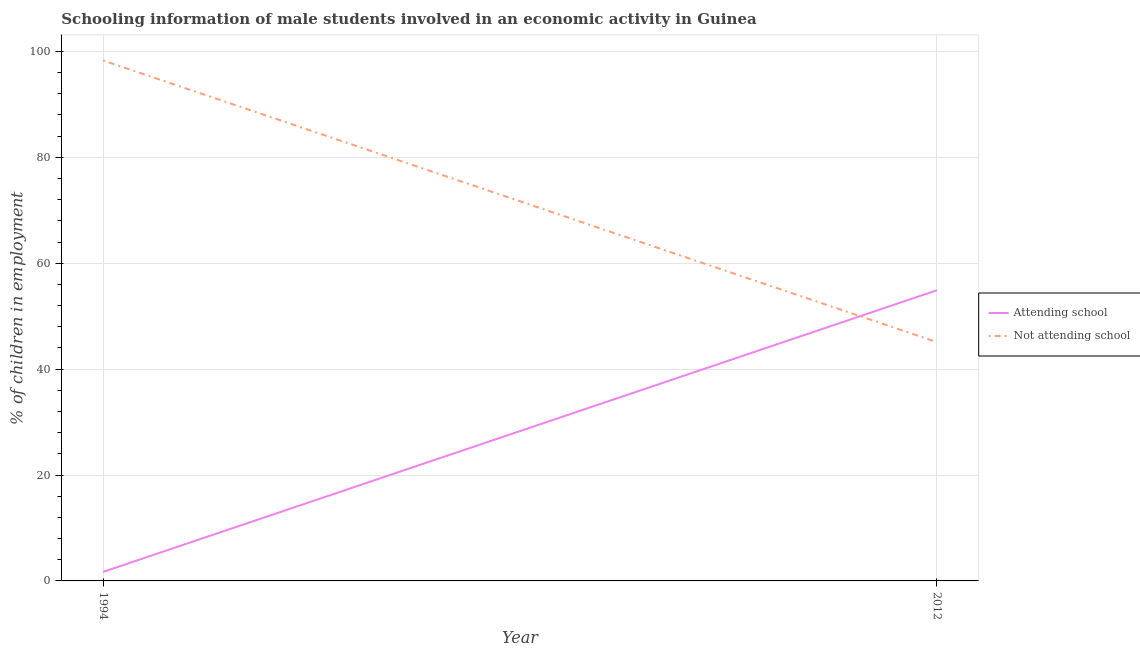Is the number of lines equal to the number of legend labels?
Your response must be concise. Yes. What is the percentage of employed males who are attending school in 2012?
Keep it short and to the point. 54.9. Across all years, what is the maximum percentage of employed males who are not attending school?
Make the answer very short. 98.3. Across all years, what is the minimum percentage of employed males who are attending school?
Keep it short and to the point. 1.7. In which year was the percentage of employed males who are attending school maximum?
Offer a terse response. 2012. In which year was the percentage of employed males who are not attending school minimum?
Ensure brevity in your answer.  2012. What is the total percentage of employed males who are attending school in the graph?
Ensure brevity in your answer.  56.6. What is the difference between the percentage of employed males who are not attending school in 1994 and that in 2012?
Provide a succinct answer. 53.2. What is the difference between the percentage of employed males who are attending school in 1994 and the percentage of employed males who are not attending school in 2012?
Offer a terse response. -43.4. What is the average percentage of employed males who are attending school per year?
Offer a terse response. 28.3. In the year 1994, what is the difference between the percentage of employed males who are not attending school and percentage of employed males who are attending school?
Your answer should be compact. 96.6. In how many years, is the percentage of employed males who are attending school greater than 16 %?
Your answer should be very brief. 1. What is the ratio of the percentage of employed males who are not attending school in 1994 to that in 2012?
Provide a succinct answer. 2.18. Is the percentage of employed males who are not attending school in 1994 less than that in 2012?
Offer a very short reply. No. Is the percentage of employed males who are not attending school strictly greater than the percentage of employed males who are attending school over the years?
Provide a short and direct response. No. What is the difference between two consecutive major ticks on the Y-axis?
Your answer should be very brief. 20. Are the values on the major ticks of Y-axis written in scientific E-notation?
Offer a very short reply. No. Does the graph contain any zero values?
Offer a very short reply. No. Does the graph contain grids?
Offer a terse response. Yes. Where does the legend appear in the graph?
Provide a succinct answer. Center right. How are the legend labels stacked?
Offer a terse response. Vertical. What is the title of the graph?
Your response must be concise. Schooling information of male students involved in an economic activity in Guinea. What is the label or title of the X-axis?
Your answer should be compact. Year. What is the label or title of the Y-axis?
Provide a short and direct response. % of children in employment. What is the % of children in employment in Not attending school in 1994?
Your answer should be compact. 98.3. What is the % of children in employment of Attending school in 2012?
Give a very brief answer. 54.9. What is the % of children in employment in Not attending school in 2012?
Provide a succinct answer. 45.1. Across all years, what is the maximum % of children in employment in Attending school?
Provide a short and direct response. 54.9. Across all years, what is the maximum % of children in employment of Not attending school?
Keep it short and to the point. 98.3. Across all years, what is the minimum % of children in employment of Not attending school?
Your answer should be compact. 45.1. What is the total % of children in employment of Attending school in the graph?
Offer a terse response. 56.6. What is the total % of children in employment in Not attending school in the graph?
Provide a succinct answer. 143.4. What is the difference between the % of children in employment of Attending school in 1994 and that in 2012?
Provide a succinct answer. -53.2. What is the difference between the % of children in employment in Not attending school in 1994 and that in 2012?
Ensure brevity in your answer.  53.2. What is the difference between the % of children in employment in Attending school in 1994 and the % of children in employment in Not attending school in 2012?
Offer a very short reply. -43.4. What is the average % of children in employment of Attending school per year?
Make the answer very short. 28.3. What is the average % of children in employment of Not attending school per year?
Provide a short and direct response. 71.7. In the year 1994, what is the difference between the % of children in employment in Attending school and % of children in employment in Not attending school?
Provide a succinct answer. -96.6. In the year 2012, what is the difference between the % of children in employment of Attending school and % of children in employment of Not attending school?
Your answer should be compact. 9.8. What is the ratio of the % of children in employment of Attending school in 1994 to that in 2012?
Provide a succinct answer. 0.03. What is the ratio of the % of children in employment of Not attending school in 1994 to that in 2012?
Offer a terse response. 2.18. What is the difference between the highest and the second highest % of children in employment in Attending school?
Offer a terse response. 53.2. What is the difference between the highest and the second highest % of children in employment in Not attending school?
Keep it short and to the point. 53.2. What is the difference between the highest and the lowest % of children in employment in Attending school?
Your answer should be compact. 53.2. What is the difference between the highest and the lowest % of children in employment in Not attending school?
Your answer should be very brief. 53.2. 